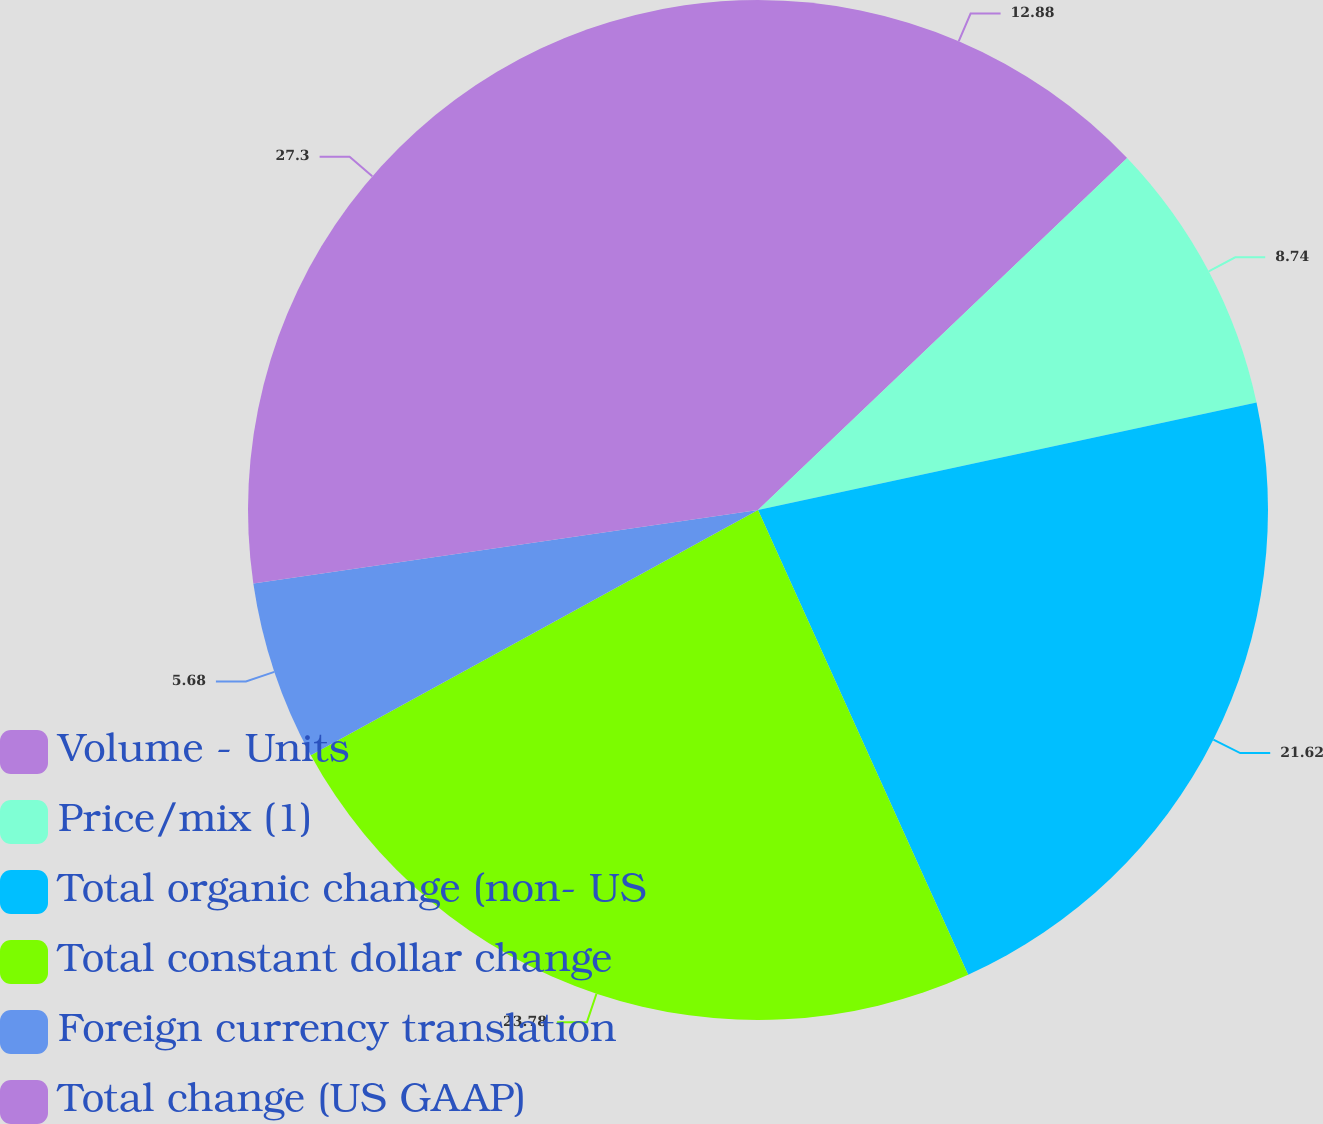Convert chart to OTSL. <chart><loc_0><loc_0><loc_500><loc_500><pie_chart><fcel>Volume - Units<fcel>Price/mix (1)<fcel>Total organic change (non- US<fcel>Total constant dollar change<fcel>Foreign currency translation<fcel>Total change (US GAAP)<nl><fcel>12.88%<fcel>8.74%<fcel>21.62%<fcel>23.78%<fcel>5.68%<fcel>27.3%<nl></chart> 